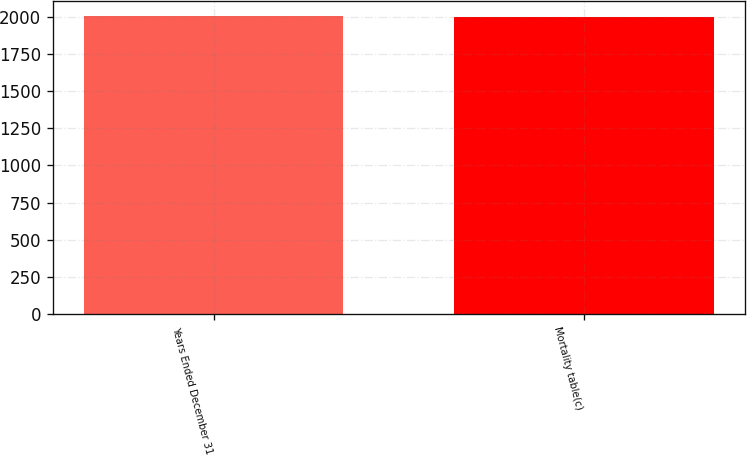Convert chart to OTSL. <chart><loc_0><loc_0><loc_500><loc_500><bar_chart><fcel>Years Ended December 31<fcel>Mortality table(c)<nl><fcel>2006<fcel>2000<nl></chart> 